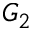Convert formula to latex. <formula><loc_0><loc_0><loc_500><loc_500>G _ { 2 }</formula> 